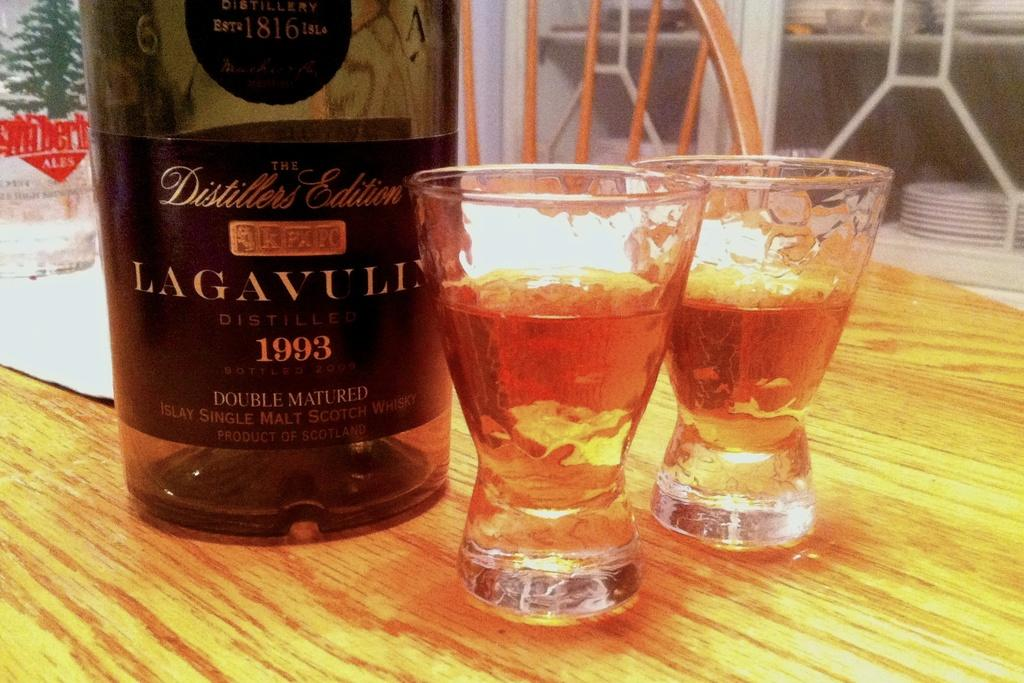Provide a one-sentence caption for the provided image. Two glasses of liquor are sitting in front of a bottle of 1993 Lagavull on a table. 